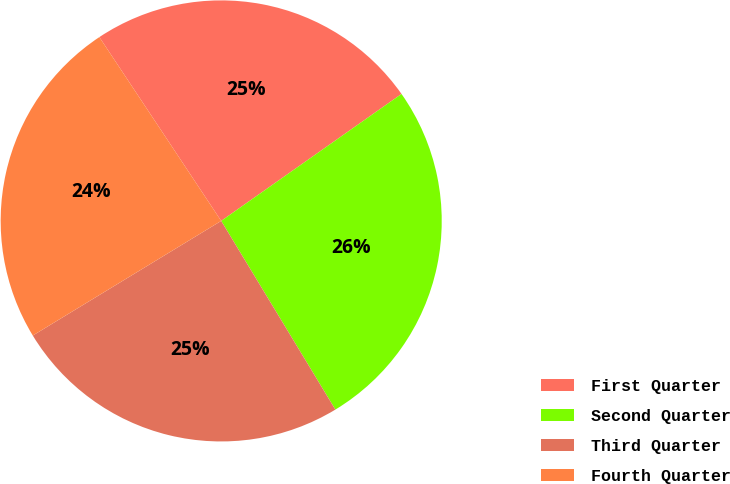<chart> <loc_0><loc_0><loc_500><loc_500><pie_chart><fcel>First Quarter<fcel>Second Quarter<fcel>Third Quarter<fcel>Fourth Quarter<nl><fcel>24.55%<fcel>26.1%<fcel>24.96%<fcel>24.38%<nl></chart> 